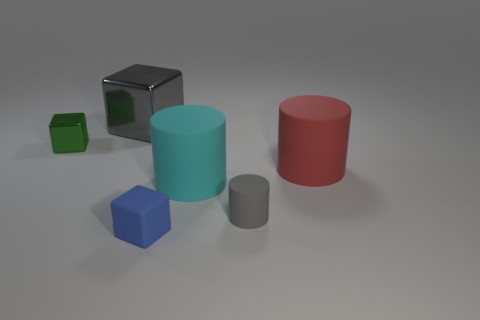What is the color of the block that is made of the same material as the tiny gray cylinder?
Ensure brevity in your answer.  Blue. How many red cylinders are the same material as the gray cube?
Your answer should be very brief. 0. Is the material of the small cylinder the same as the big cylinder that is behind the cyan object?
Ensure brevity in your answer.  Yes. How many objects are shiny cubes left of the big gray metallic object or tiny gray metallic blocks?
Ensure brevity in your answer.  1. How big is the gray rubber thing behind the blue block that is right of the metal cube that is behind the small green metal thing?
Your answer should be compact. Small. There is a small object that is the same color as the big metallic block; what material is it?
Offer a very short reply. Rubber. Are there any other things that have the same shape as the big cyan rubber object?
Offer a terse response. Yes. There is a gray thing behind the large cylinder on the right side of the small gray cylinder; what size is it?
Make the answer very short. Large. How many big objects are green metallic things or blue cylinders?
Provide a short and direct response. 0. Is the number of big cyan rubber blocks less than the number of red cylinders?
Your answer should be compact. Yes. 